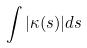<formula> <loc_0><loc_0><loc_500><loc_500>\int | \kappa ( s ) | d s</formula> 